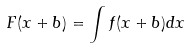Convert formula to latex. <formula><loc_0><loc_0><loc_500><loc_500>F ( x + b ) = \int f ( x + b ) d x</formula> 